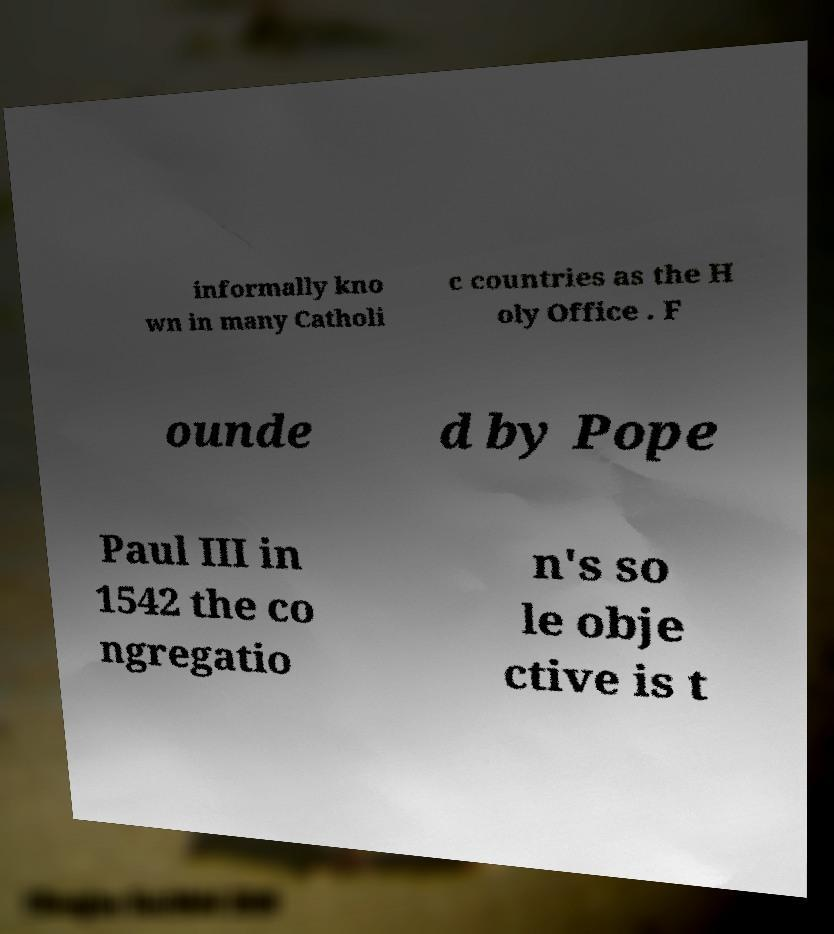I need the written content from this picture converted into text. Can you do that? informally kno wn in many Catholi c countries as the H oly Office . F ounde d by Pope Paul III in 1542 the co ngregatio n's so le obje ctive is t 